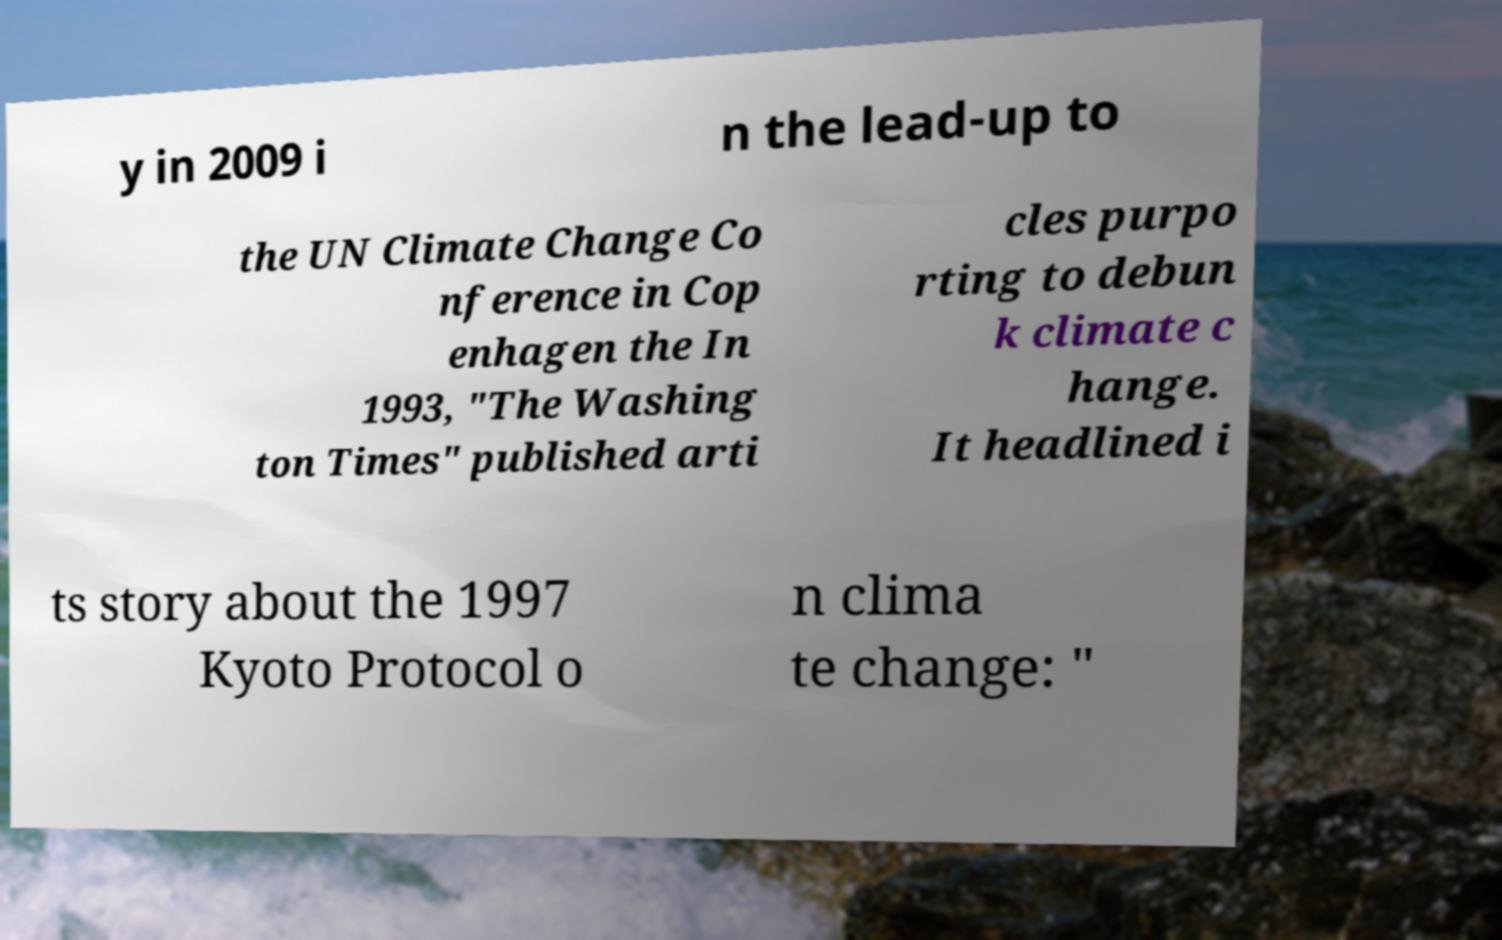What messages or text are displayed in this image? I need them in a readable, typed format. y in 2009 i n the lead-up to the UN Climate Change Co nference in Cop enhagen the In 1993, "The Washing ton Times" published arti cles purpo rting to debun k climate c hange. It headlined i ts story about the 1997 Kyoto Protocol o n clima te change: " 